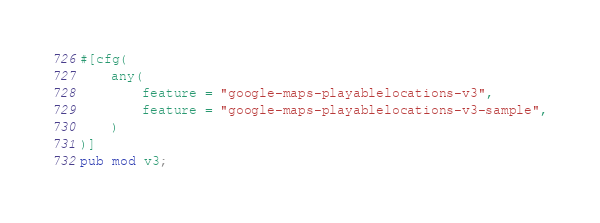Convert code to text. <code><loc_0><loc_0><loc_500><loc_500><_Rust_>#[cfg(
    any(
        feature = "google-maps-playablelocations-v3",
        feature = "google-maps-playablelocations-v3-sample",
    )
)]
pub mod v3;
</code> 